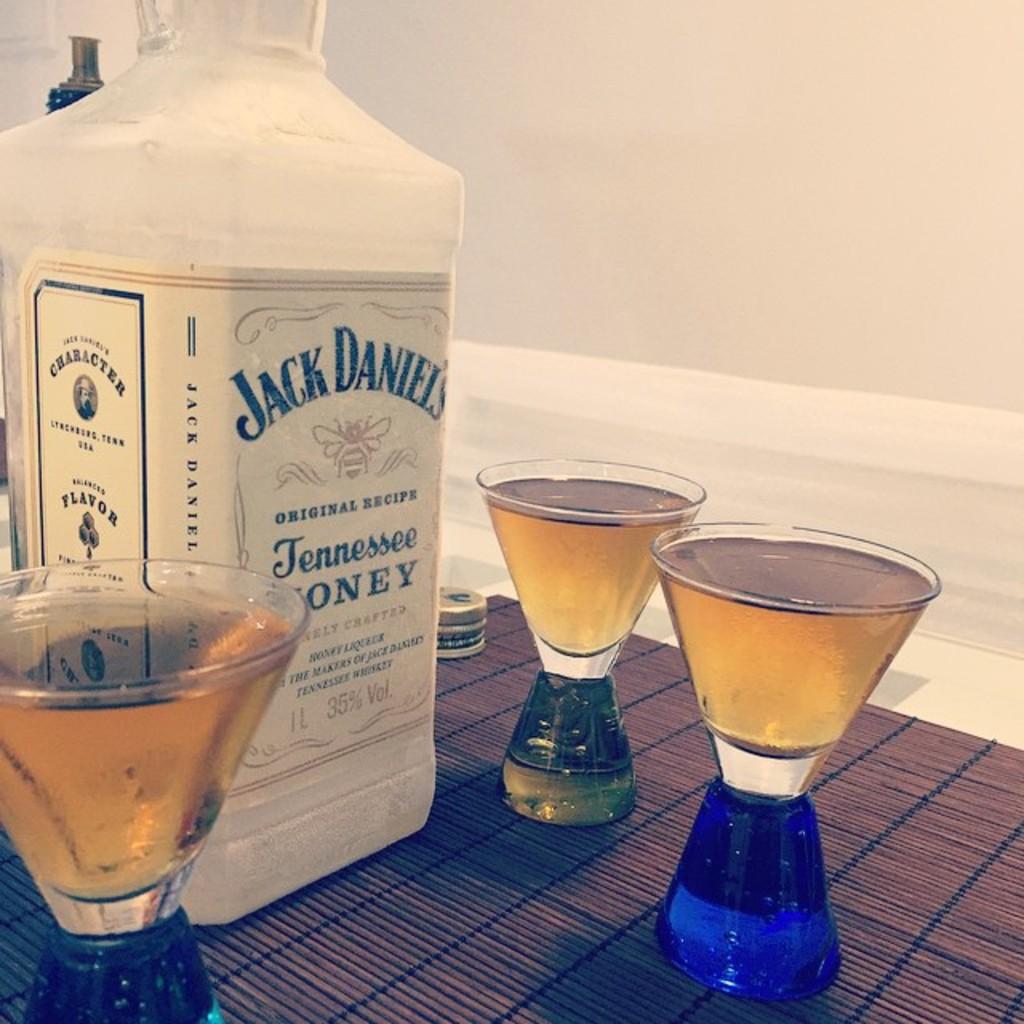What recipe is this wiskey?
Your answer should be very brief. Original. 